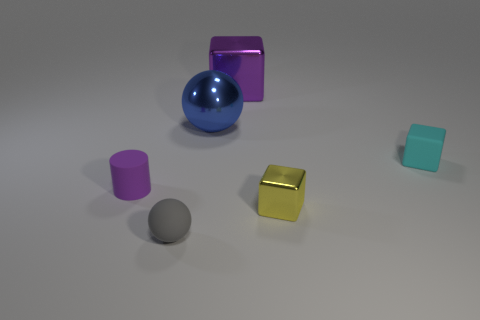Can you tell me what materials the objects in the image seem to be made of? Certainly! The image displays objects that appear to be made from different materials: the large block looks metallic with a reflective surface, the spherical object has a glossy finish suggestive of either polished metal or plastic, and the various cylinders and the cube seem to be made of either matte plastic or rubber, given their non-reflective surfaces. 